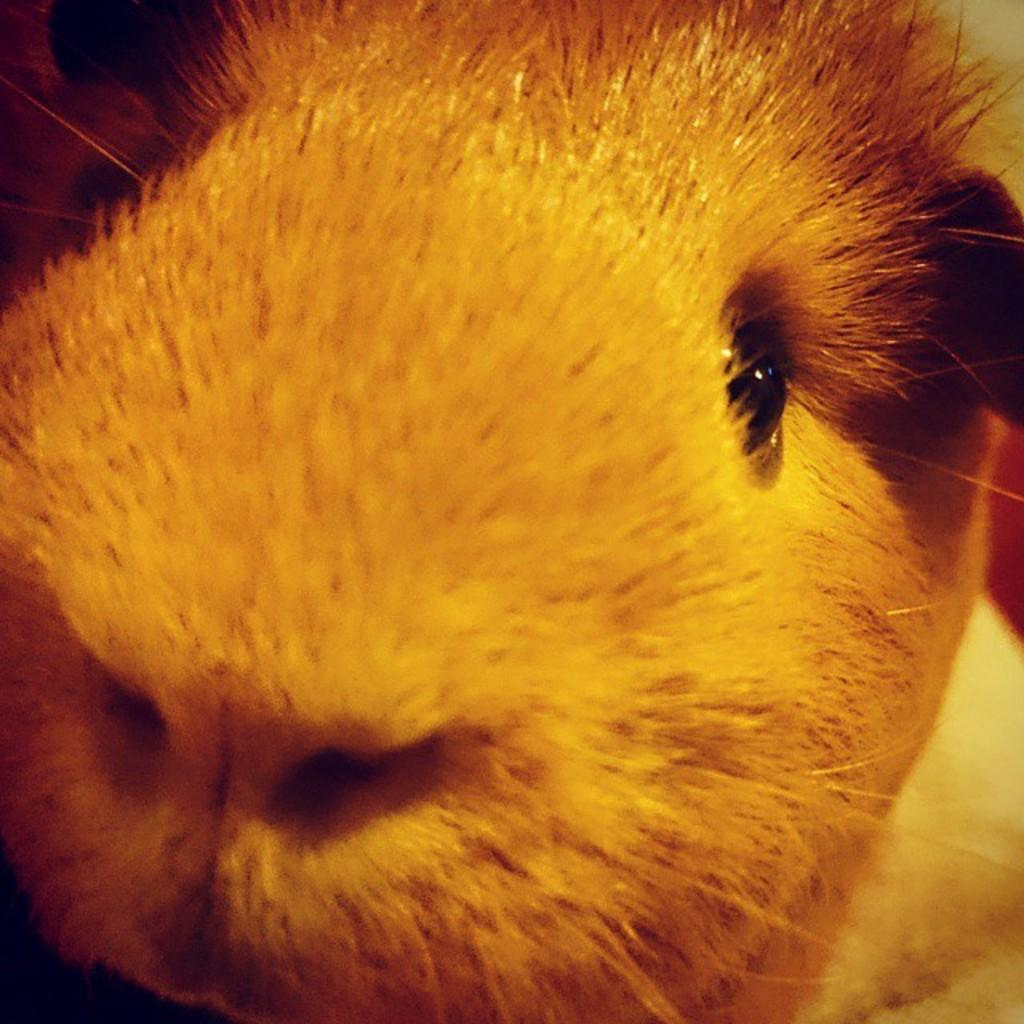What type of creature is present in the image? There is an animal in the image. Can you describe the color of the animal? The animal might be white. How many stomachs does the animal have in the image? There is no information about the animal's stomachs in the image, so it cannot be determined. 